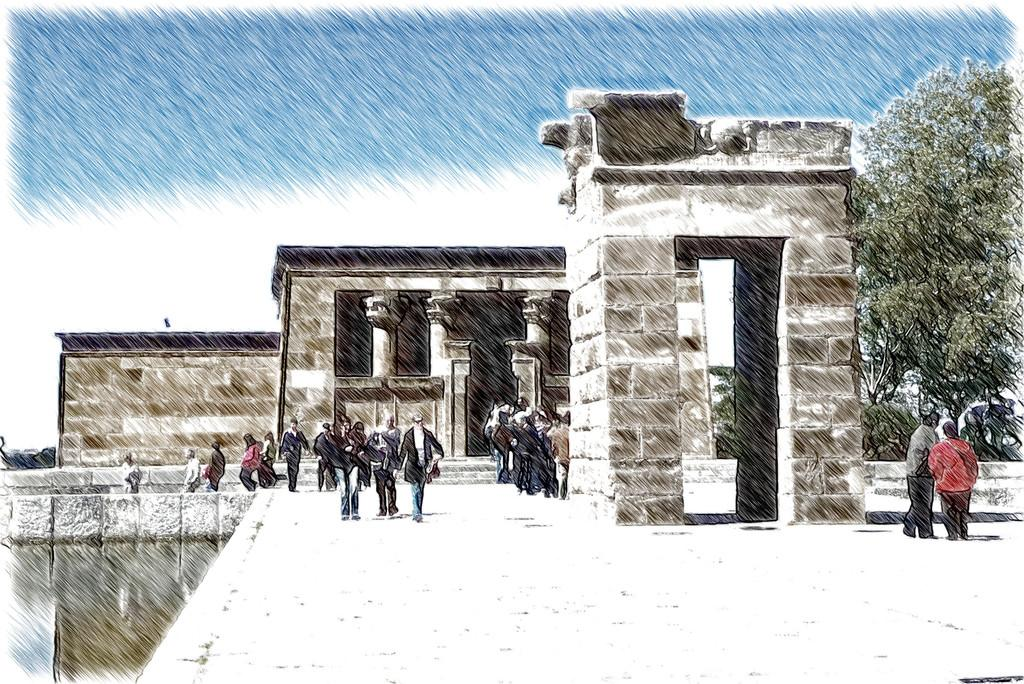What are the people in the image doing? The persons in the front of the image are standing and walking. What can be seen on the right side of the image? There is a tree on the right side of the image. What type of structures are in the center of the image? There are buildings in the center of the image. How many eggs are on the scale in the image? There is no scale or eggs present in the image. Who is the writer in the image? There is no writer present in the image. 